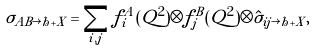Convert formula to latex. <formula><loc_0><loc_0><loc_500><loc_500>\sigma _ { A B \rightarrow h + X } = \sum _ { i , j } f _ { i } ^ { A } ( Q ^ { 2 } ) \otimes f _ { j } ^ { B } ( Q ^ { 2 } ) \otimes \hat { \sigma } _ { i j \rightarrow h + X } ,</formula> 